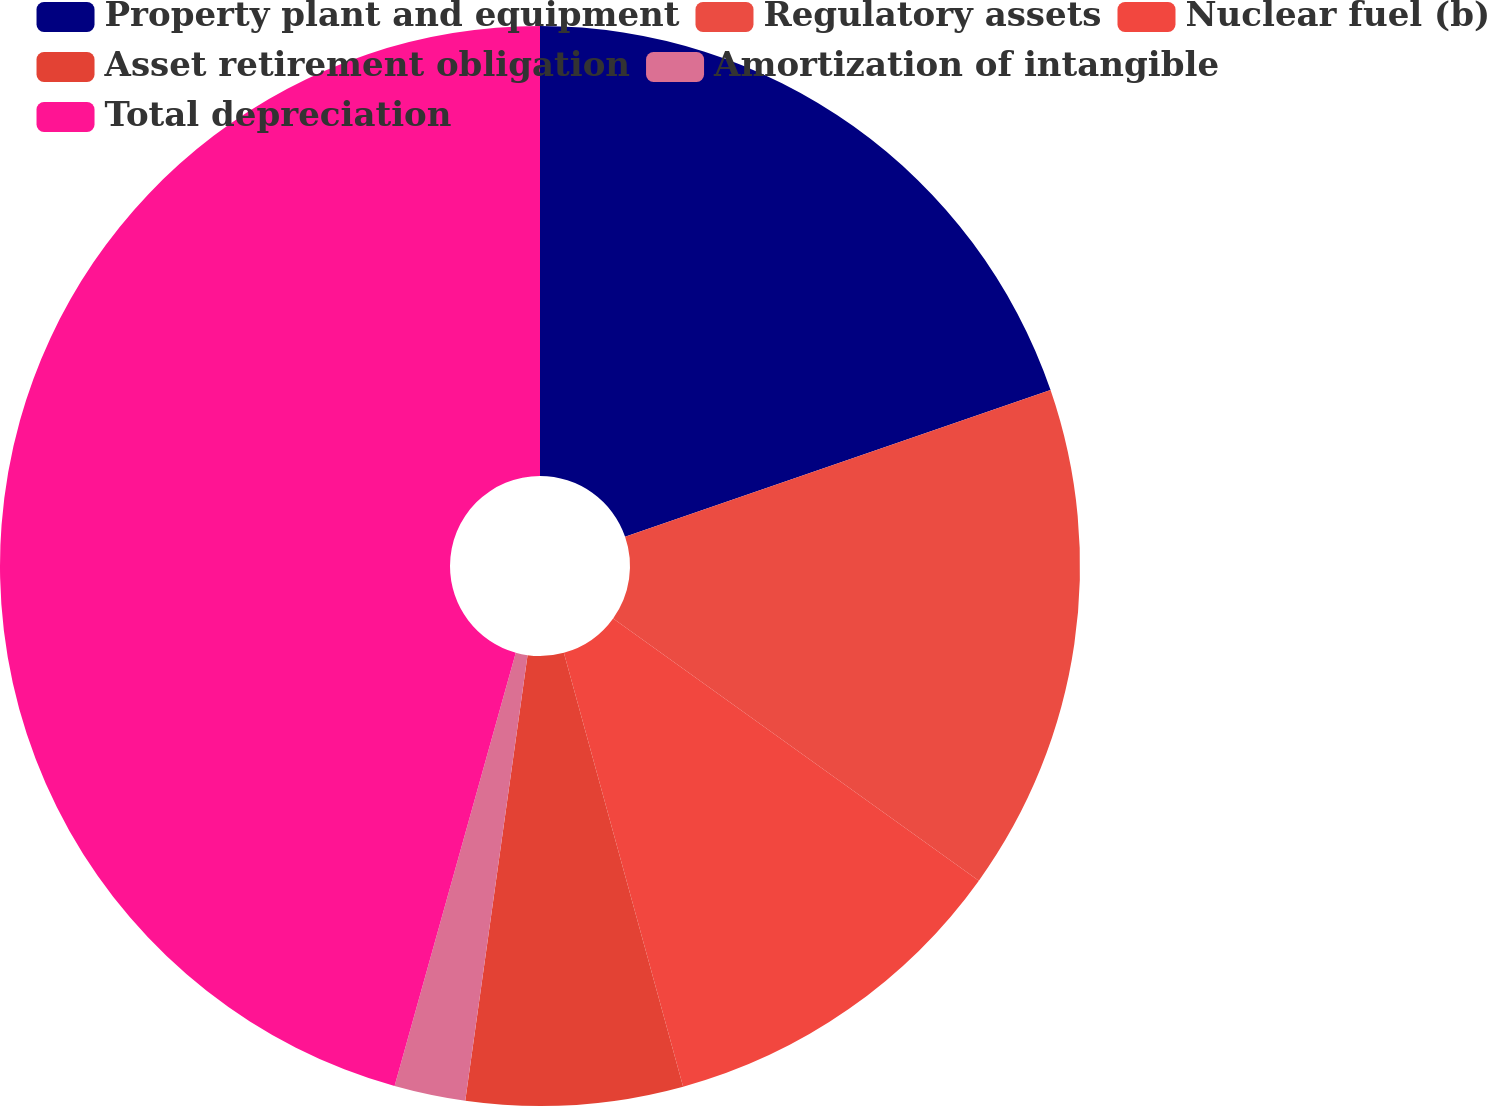Convert chart. <chart><loc_0><loc_0><loc_500><loc_500><pie_chart><fcel>Property plant and equipment<fcel>Regulatory assets<fcel>Nuclear fuel (b)<fcel>Asset retirement obligation<fcel>Amortization of intangible<fcel>Total depreciation<nl><fcel>19.72%<fcel>15.18%<fcel>10.83%<fcel>6.48%<fcel>2.13%<fcel>45.66%<nl></chart> 